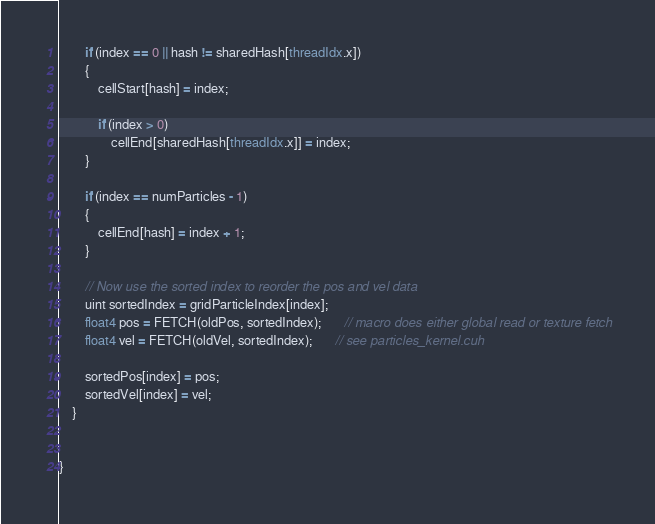Convert code to text. <code><loc_0><loc_0><loc_500><loc_500><_Cuda_>        if (index == 0 || hash != sharedHash[threadIdx.x])
        {
            cellStart[hash] = index;

            if (index > 0)
                cellEnd[sharedHash[threadIdx.x]] = index;
        }

        if (index == numParticles - 1)
        {
            cellEnd[hash] = index + 1;
        }

        // Now use the sorted index to reorder the pos and vel data
        uint sortedIndex = gridParticleIndex[index];
        float4 pos = FETCH(oldPos, sortedIndex);       // macro does either global read or texture fetch
        float4 vel = FETCH(oldVel, sortedIndex);       // see particles_kernel.cuh

        sortedPos[index] = pos;
        sortedVel[index] = vel;
    }


}
</code> 